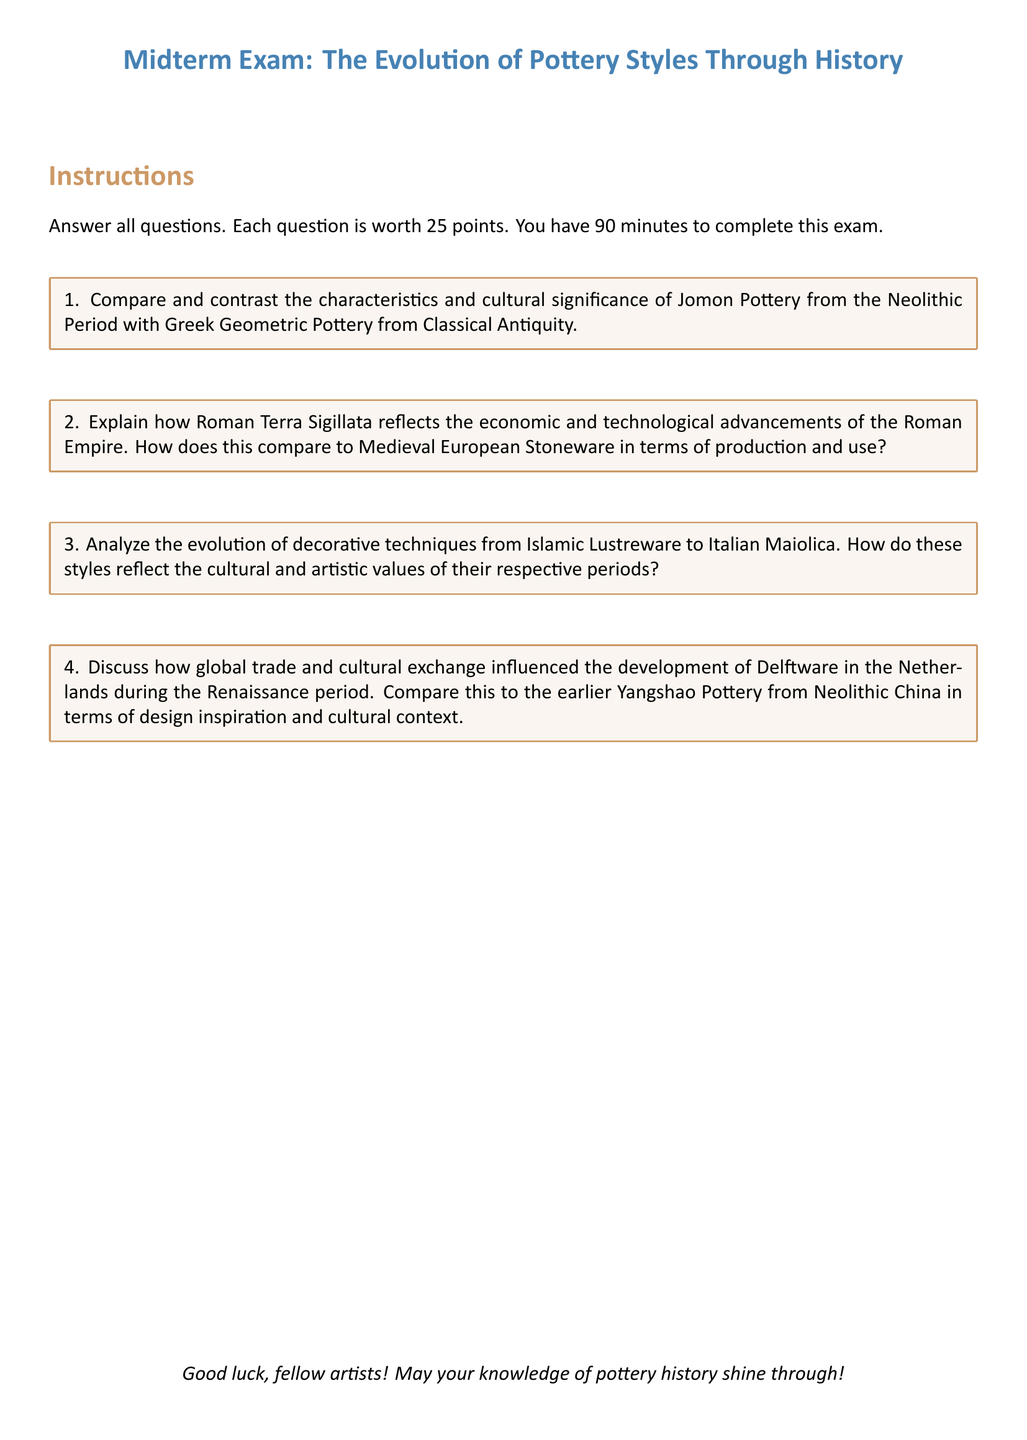What is the title of the midterm exam? The title of the midterm exam is provided in the header of the document.
Answer: The Evolution of Pottery Styles Through History How many points is each question worth? Each question's worth is clearly mentioned in the instructions of the exam document.
Answer: 25 points What is the duration of the exam? The duration for completing the exam is specified in the instructions section of the document.
Answer: 90 minutes Which pottery styles are compared in question 1? The specific pottery styles mentioned in question 1 help identify the main focus of that question.
Answer: Jomon Pottery and Greek Geometric Pottery What two pottery styles are analyzed for decorative techniques in question 3? The styles listed in question 3 indicate the comparative analysis required.
Answer: Islamic Lustreware and Italian Maiolica What cultural context is referenced in question 4? The reference in question 4 indicates the backdrop against which Delftware and Yangshao Pottery are compared.
Answer: Global trade and cultural exchange What does Terra Sigillata reflect according to question 2? Question 2 states a specific aspect of Terra Sigillata relevant to the Roman Empire's context.
Answer: Economic and technological advancements In which period is Delftware developed? The development period of Delftware is mentioned in the context of question 4 to set a historical timeframe.
Answer: Renaissance period 